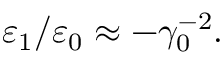Convert formula to latex. <formula><loc_0><loc_0><loc_500><loc_500>\varepsilon _ { 1 } / \varepsilon _ { 0 } \approx - \gamma _ { 0 } ^ { - 2 } .</formula> 